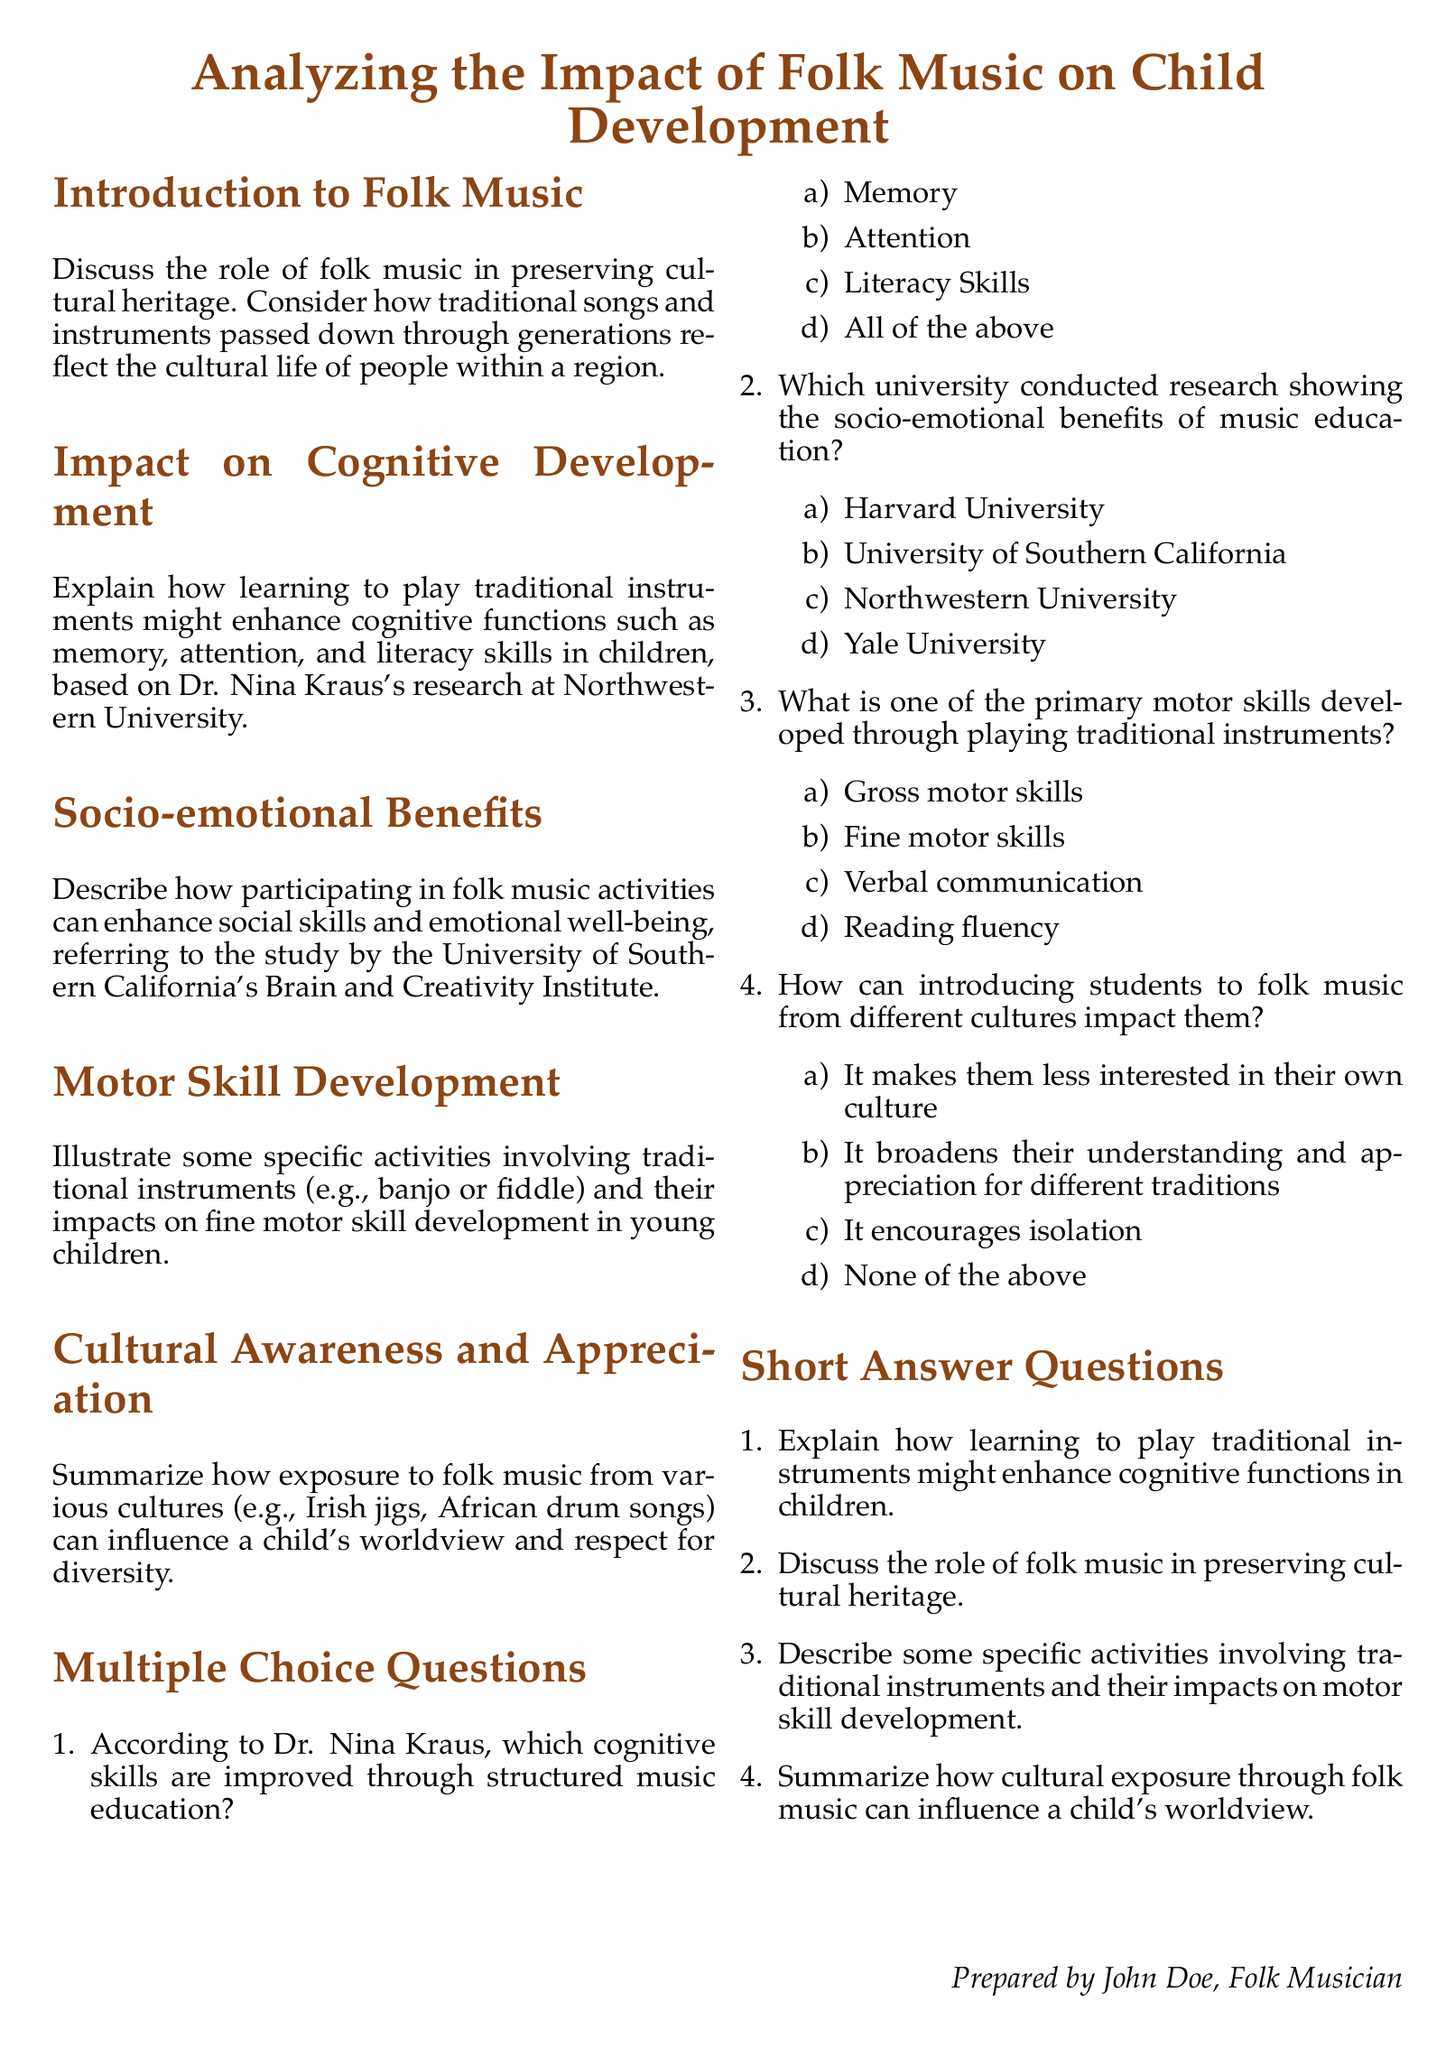What is the title of the document? The title of the document is a clear statement found at the top of the rendered document.
Answer: Analyzing the Impact of Folk Music on Child Development Who conducted research on cognitive development related to folk music? The document mentions Dr. Nina Kraus and connects her research to cognitive development, specifically at a particular institution.
Answer: Northwestern University Which university is associated with socio-emotional benefits of music education? The document specifically mentions the university that conducted the relevant study on socio-emotional benefits.
Answer: University of Southern California What is one primary benefit of playing traditional instruments listed in the document? The document outlines various benefits, focusing on motor skill development in children through traditional instruments.
Answer: Fine motor skills Summarize how exposure to folk music influences a child's worldview. The document discusses the positive impacts of cultural exposure on children, as derived from folk music education.
Answer: Broadens understanding and appreciation for different traditions What is one of the activities mentioned that impacts motor skill development? The document refers to specific traditional instruments and associated activities affecting children's motor skills.
Answer: Banjo or fiddle What are two cognitive skills improved through music education according to the document? The document states several cognitive skills related to music education based on specific research findings.
Answer: Memory, Attention What type of music is mentioned when discussing cultural awareness? The document gives examples of traditional music styles connected to cultural awareness in children.
Answer: Irish jigs, African drum songs 